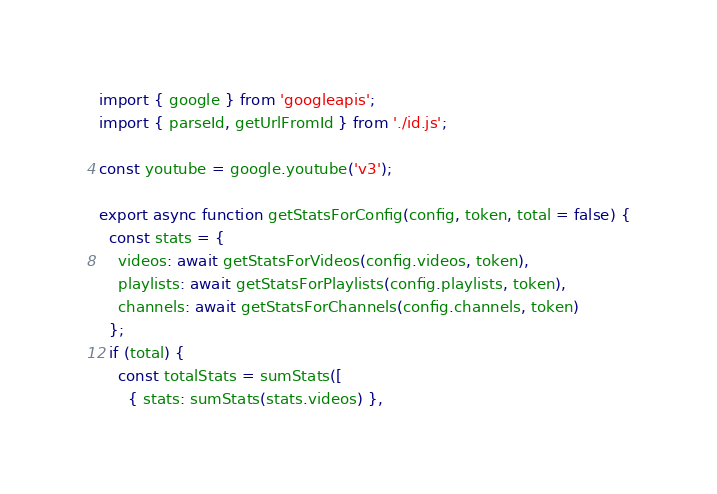<code> <loc_0><loc_0><loc_500><loc_500><_JavaScript_>import { google } from 'googleapis';
import { parseId, getUrlFromId } from './id.js';

const youtube = google.youtube('v3');

export async function getStatsForConfig(config, token, total = false) {
  const stats = {
    videos: await getStatsForVideos(config.videos, token),
    playlists: await getStatsForPlaylists(config.playlists, token),
    channels: await getStatsForChannels(config.channels, token)
  };
  if (total) {
    const totalStats = sumStats([
      { stats: sumStats(stats.videos) },</code> 